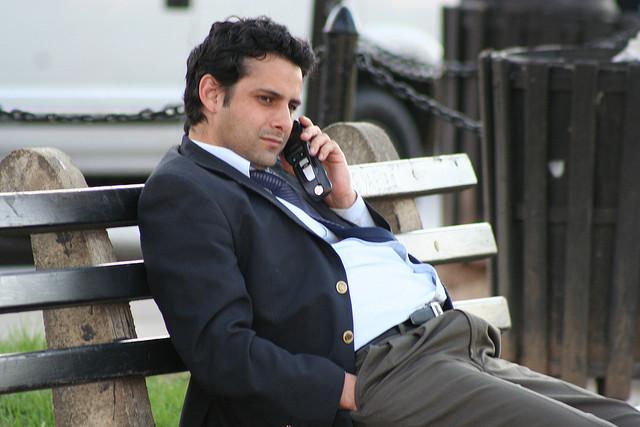Is this man talking on the phone?
Answer briefly. Yes. Does this man look serious?
Give a very brief answer. Yes. Is he outside?
Be succinct. Yes. 